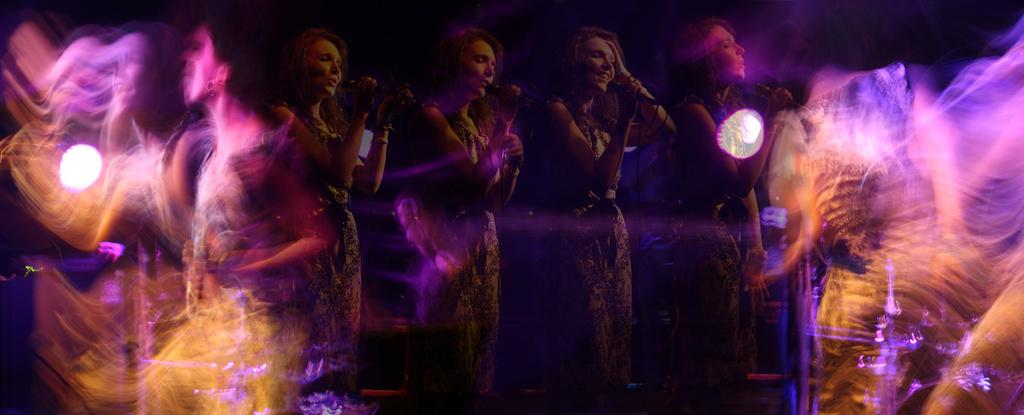Who is the main subject in the image? There is a lady in the image. What is the lady doing in the image? The lady is singing on a stage. How would you describe the quality of the image? The image appears to be blurry and digital. Can you see a river flowing in the background of the image? There is no river visible in the image; it features a lady singing on a stage. What type of truck is parked next to the stage in the image? There is no truck present in the image; it only shows a lady singing on a stage. 